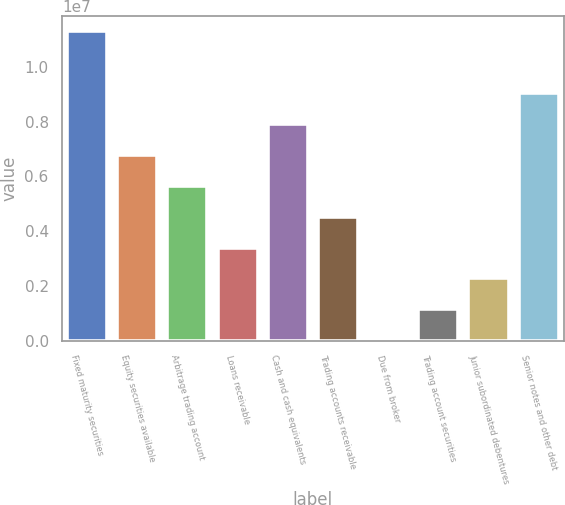<chart> <loc_0><loc_0><loc_500><loc_500><bar_chart><fcel>Fixed maturity securities<fcel>Equity securities available<fcel>Arbitrage trading account<fcel>Loans receivable<fcel>Cash and cash equivalents<fcel>Trading accounts receivable<fcel>Due from broker<fcel>Trading account securities<fcel>Junior subordinated debentures<fcel>Senior notes and other debt<nl><fcel>1.1312e+07<fcel>6.79157e+06<fcel>5.66146e+06<fcel>3.40122e+06<fcel>7.92169e+06<fcel>4.53134e+06<fcel>10875<fcel>1.14099e+06<fcel>2.27111e+06<fcel>9.0518e+06<nl></chart> 